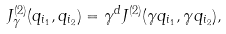<formula> <loc_0><loc_0><loc_500><loc_500>J _ { \gamma } ^ { ( 2 ) } ( q _ { i _ { 1 } } , q _ { i _ { 2 } } ) = \gamma ^ { d } J ^ { ( 2 ) } ( \gamma q _ { i _ { 1 } } , \gamma q _ { i _ { 2 } } ) ,</formula> 